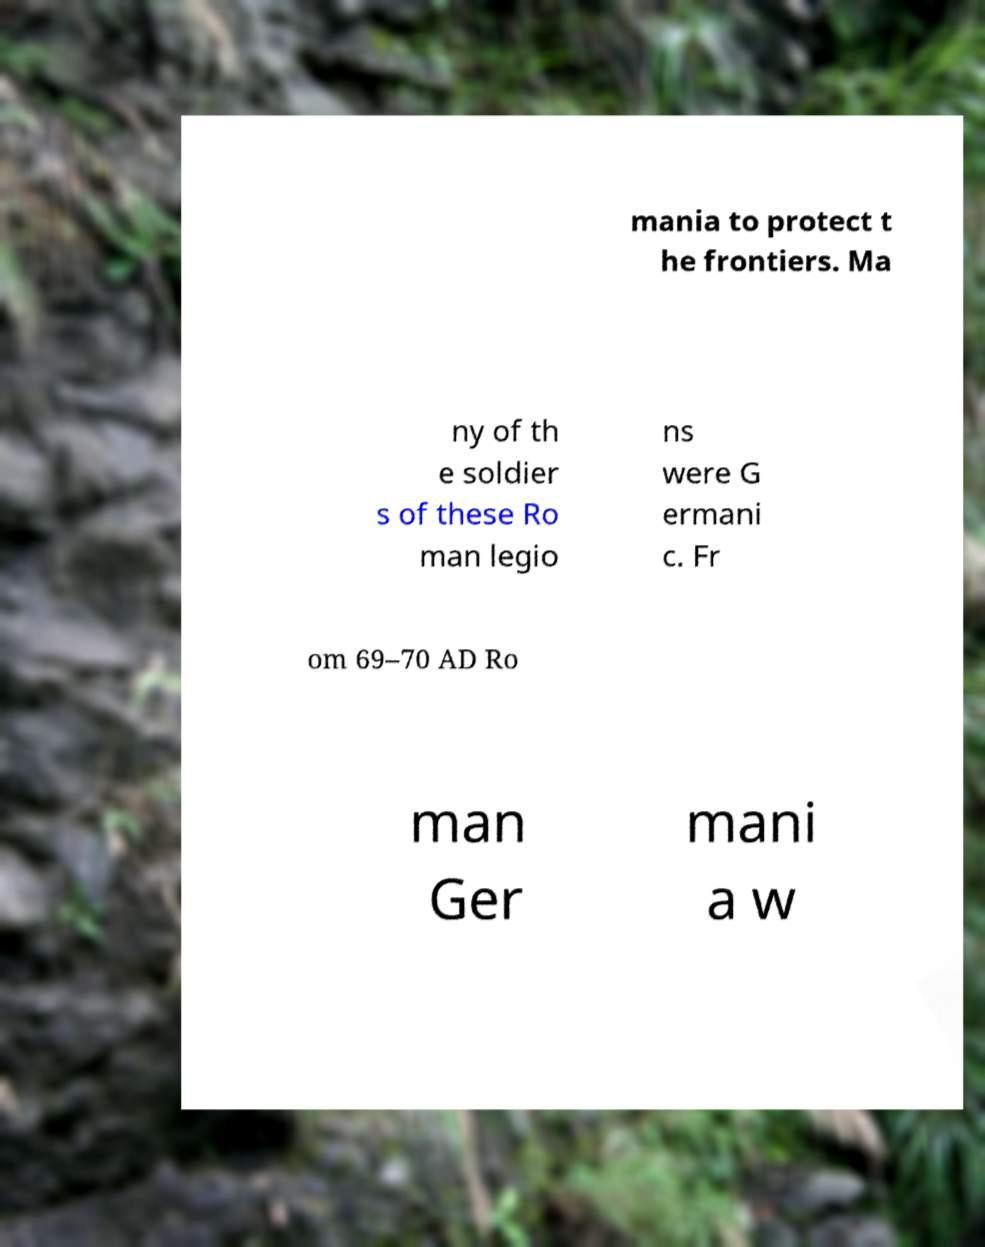What messages or text are displayed in this image? I need them in a readable, typed format. mania to protect t he frontiers. Ma ny of th e soldier s of these Ro man legio ns were G ermani c. Fr om 69–70 AD Ro man Ger mani a w 